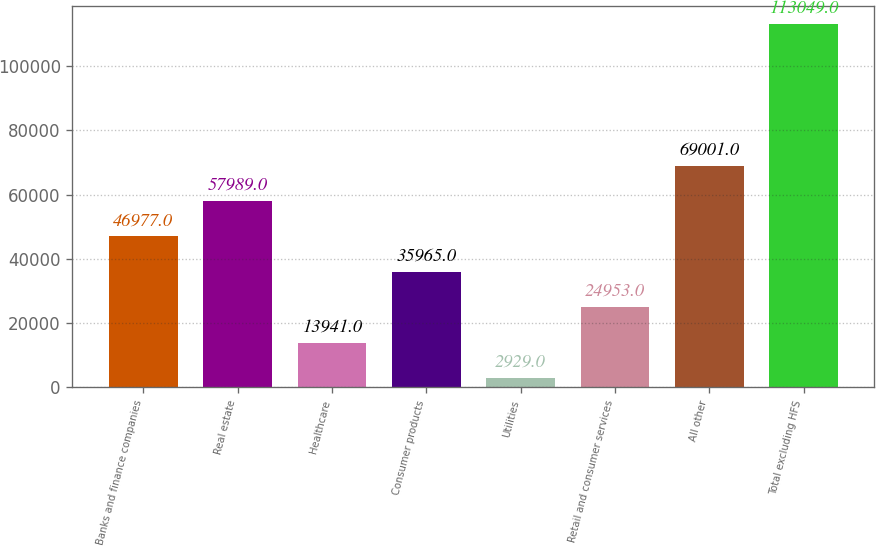<chart> <loc_0><loc_0><loc_500><loc_500><bar_chart><fcel>Banks and finance companies<fcel>Real estate<fcel>Healthcare<fcel>Consumer products<fcel>Utilities<fcel>Retail and consumer services<fcel>All other<fcel>Total excluding HFS<nl><fcel>46977<fcel>57989<fcel>13941<fcel>35965<fcel>2929<fcel>24953<fcel>69001<fcel>113049<nl></chart> 